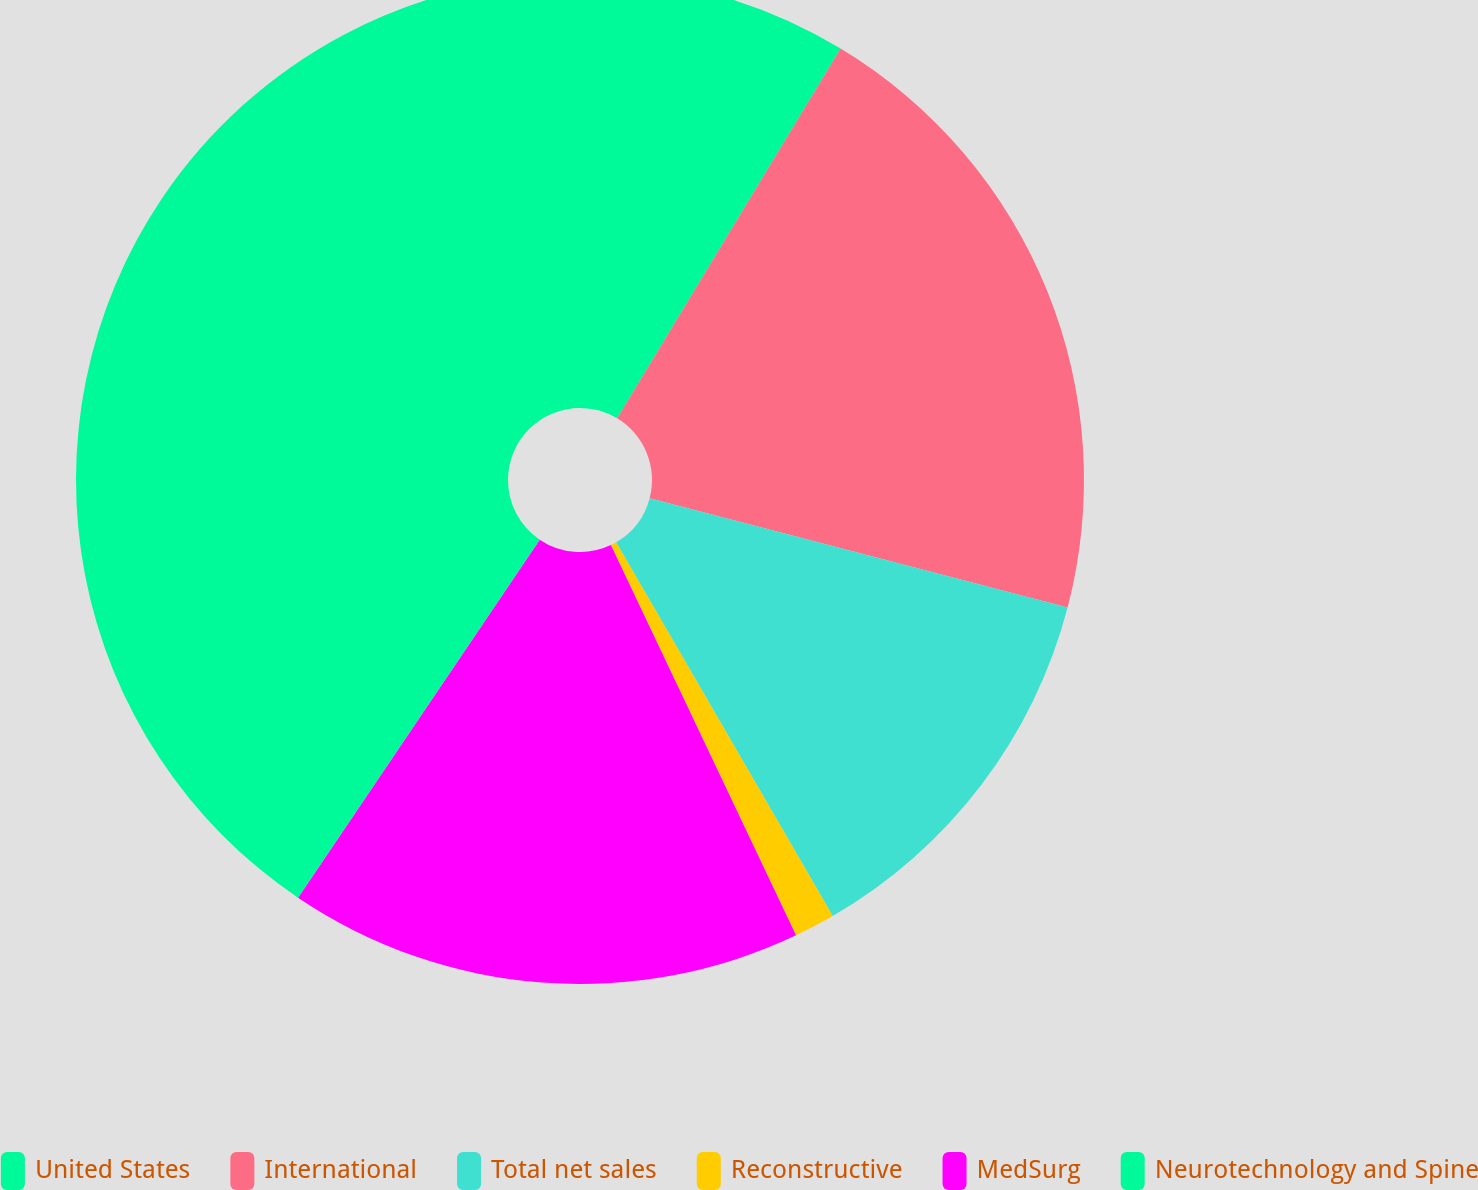<chart> <loc_0><loc_0><loc_500><loc_500><pie_chart><fcel>United States<fcel>International<fcel>Total net sales<fcel>Reconstructive<fcel>MedSurg<fcel>Neurotechnology and Spine<nl><fcel>8.65%<fcel>20.42%<fcel>12.57%<fcel>1.31%<fcel>16.5%<fcel>40.55%<nl></chart> 